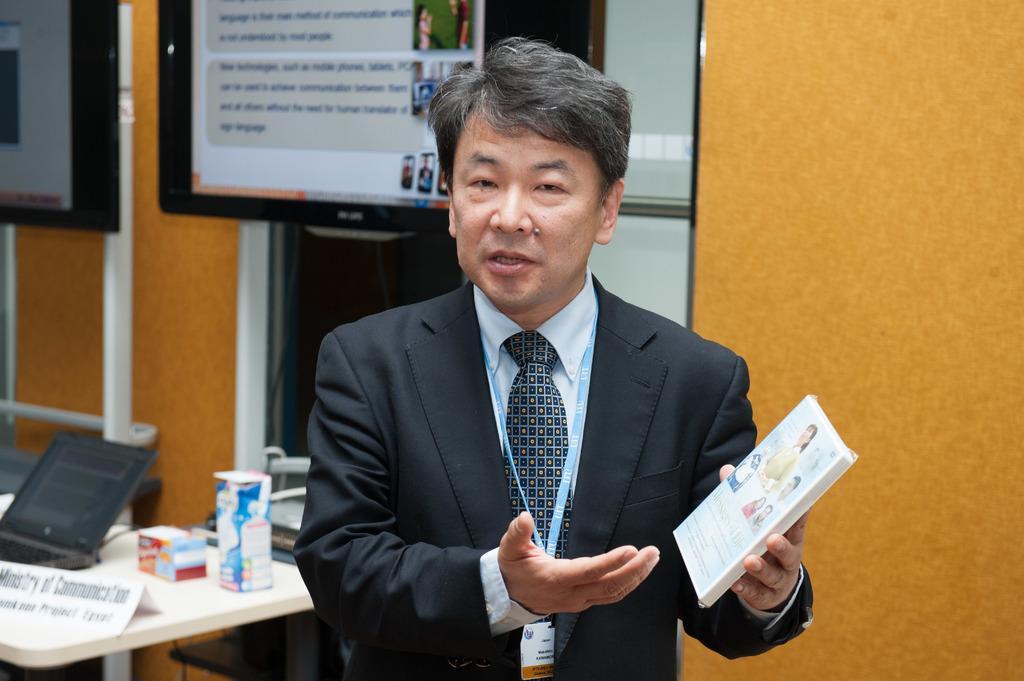Could you give a brief overview of what you see in this image? In this image I can see a person holding the box. To the left there is a table. On the table there is a laptop,paper and some of the objects. In the background there is a screen. 